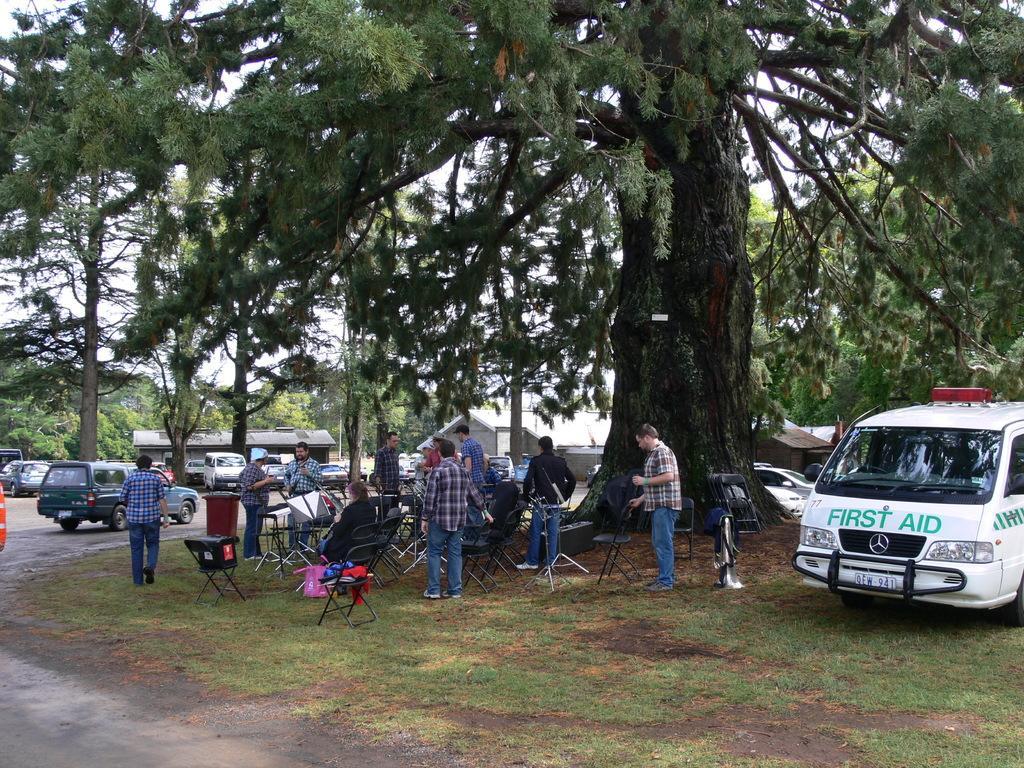Could you give a brief overview of what you see in this image? On the right side there is an ambulance. And it is written first aid on that. Near to that there is a tree. Also there are many chairs. And some people are standing there. In the back there are vehicles, buildings and trees. On the left side there is a road. On the ground there are grasses. 